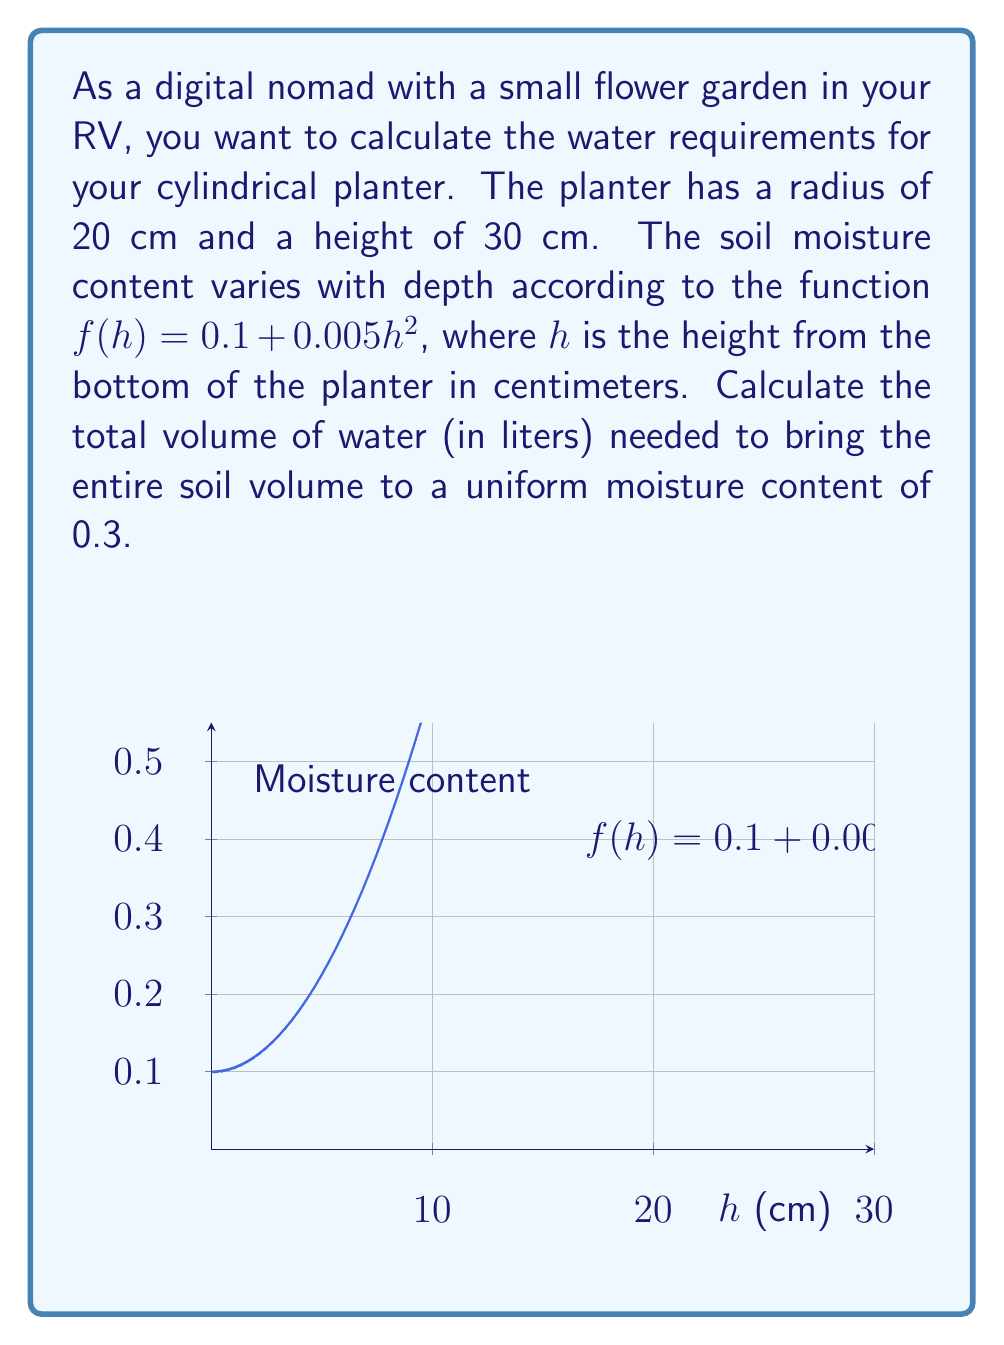Help me with this question. To solve this problem, we need to use a volume integral. Let's break it down step-by-step:

1) First, we need to find the current volume of water in the soil. This can be calculated using the following volume integral:

   $$V_{\text{current}} = \int_0^{30} \int_0^{2\pi} \int_0^{20} (0.1 + 0.005h^2) \cdot r \, dr \, d\theta \, dh$$

2) Simplify the integral:
   
   $$V_{\text{current}} = 2\pi \int_0^{30} \int_0^{20} (0.1 + 0.005h^2) \cdot r \, dr \, dh$$

3) Solve the inner integral:
   
   $$V_{\text{current}} = 2\pi \int_0^{30} [0.1r^2/2 + 0.005h^2r^2/2]_0^{20} \, dh$$
   $$= 2\pi \int_0^{30} (20 + h^2) \, dh$$

4) Solve the outer integral:
   
   $$V_{\text{current}} = 2\pi [20h + h^3/3]_0^{30}$$
   $$= 2\pi (600 + 9000) = 60200\pi \text{ cm}^3$$

5) Now, calculate the total volume of the planter:
   
   $$V_{\text{total}} = \pi r^2 h = \pi \cdot 20^2 \cdot 30 = 12000\pi \text{ cm}^3$$

6) The volume of water needed to reach a uniform moisture content of 0.3 is:
   
   $$V_{\text{needed}} = 0.3 \cdot V_{\text{total}} - V_{\text{current}}$$
   $$= 0.3 \cdot 12000\pi - 60200\pi = -56200\pi \text{ cm}^3$$

7) Convert to liters:
   
   $$V_{\text{needed}} = -56200\pi \cdot \frac{1 \text{ L}}{1000 \text{ cm}^3} \approx -176.6 \text{ L}$$

The negative result indicates that we need to remove water rather than add it.
Answer: 176.6 L of water needs to be removed. 